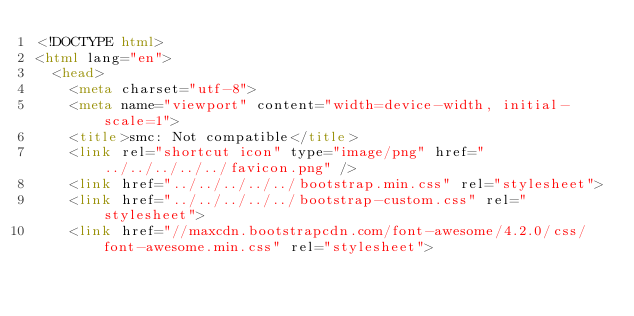Convert code to text. <code><loc_0><loc_0><loc_500><loc_500><_HTML_><!DOCTYPE html>
<html lang="en">
  <head>
    <meta charset="utf-8">
    <meta name="viewport" content="width=device-width, initial-scale=1">
    <title>smc: Not compatible</title>
    <link rel="shortcut icon" type="image/png" href="../../../../../favicon.png" />
    <link href="../../../../../bootstrap.min.css" rel="stylesheet">
    <link href="../../../../../bootstrap-custom.css" rel="stylesheet">
    <link href="//maxcdn.bootstrapcdn.com/font-awesome/4.2.0/css/font-awesome.min.css" rel="stylesheet"></code> 